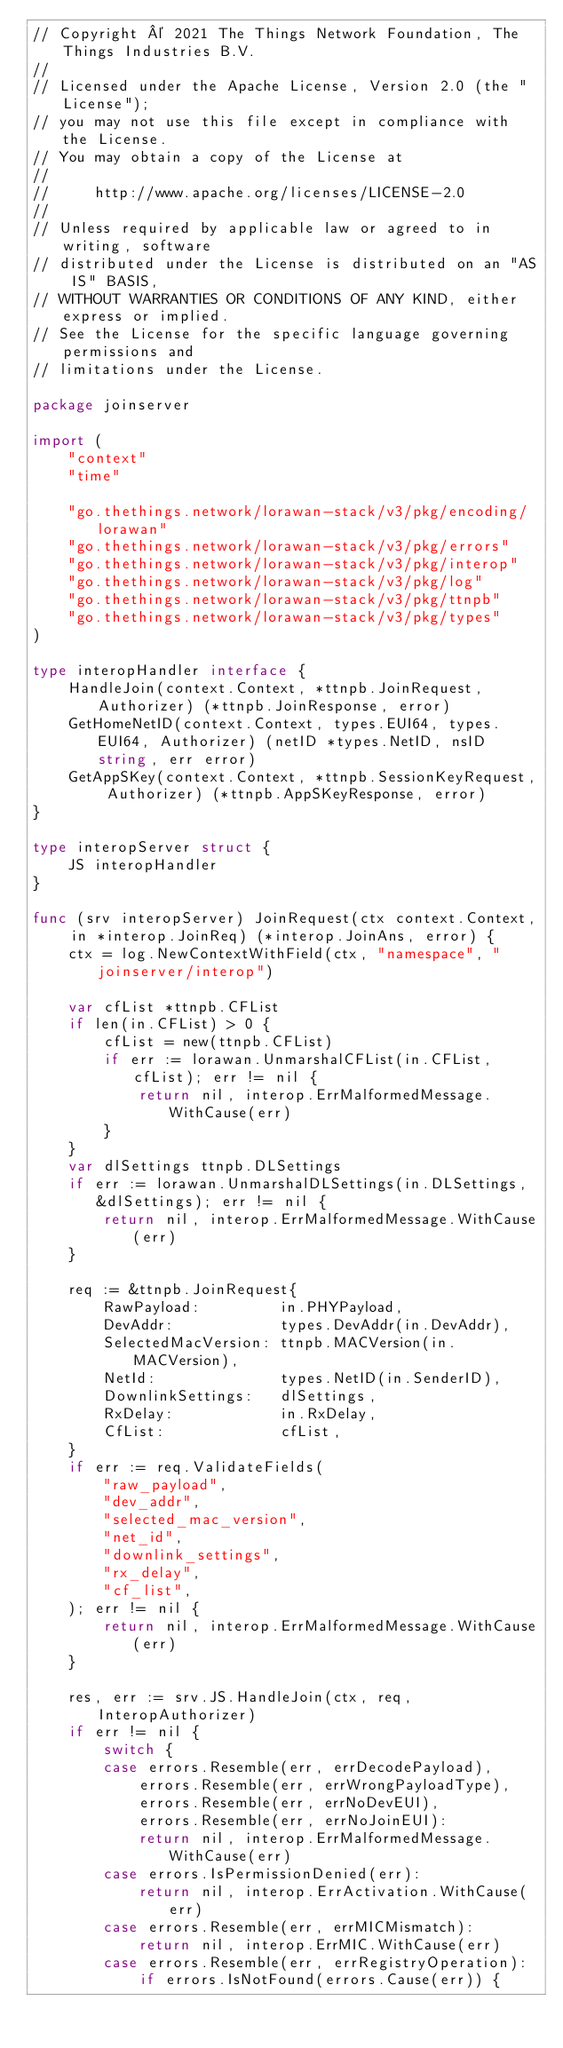<code> <loc_0><loc_0><loc_500><loc_500><_Go_>// Copyright © 2021 The Things Network Foundation, The Things Industries B.V.
//
// Licensed under the Apache License, Version 2.0 (the "License");
// you may not use this file except in compliance with the License.
// You may obtain a copy of the License at
//
//     http://www.apache.org/licenses/LICENSE-2.0
//
// Unless required by applicable law or agreed to in writing, software
// distributed under the License is distributed on an "AS IS" BASIS,
// WITHOUT WARRANTIES OR CONDITIONS OF ANY KIND, either express or implied.
// See the License for the specific language governing permissions and
// limitations under the License.

package joinserver

import (
	"context"
	"time"

	"go.thethings.network/lorawan-stack/v3/pkg/encoding/lorawan"
	"go.thethings.network/lorawan-stack/v3/pkg/errors"
	"go.thethings.network/lorawan-stack/v3/pkg/interop"
	"go.thethings.network/lorawan-stack/v3/pkg/log"
	"go.thethings.network/lorawan-stack/v3/pkg/ttnpb"
	"go.thethings.network/lorawan-stack/v3/pkg/types"
)

type interopHandler interface {
	HandleJoin(context.Context, *ttnpb.JoinRequest, Authorizer) (*ttnpb.JoinResponse, error)
	GetHomeNetID(context.Context, types.EUI64, types.EUI64, Authorizer) (netID *types.NetID, nsID string, err error)
	GetAppSKey(context.Context, *ttnpb.SessionKeyRequest, Authorizer) (*ttnpb.AppSKeyResponse, error)
}

type interopServer struct {
	JS interopHandler
}

func (srv interopServer) JoinRequest(ctx context.Context, in *interop.JoinReq) (*interop.JoinAns, error) {
	ctx = log.NewContextWithField(ctx, "namespace", "joinserver/interop")

	var cfList *ttnpb.CFList
	if len(in.CFList) > 0 {
		cfList = new(ttnpb.CFList)
		if err := lorawan.UnmarshalCFList(in.CFList, cfList); err != nil {
			return nil, interop.ErrMalformedMessage.WithCause(err)
		}
	}
	var dlSettings ttnpb.DLSettings
	if err := lorawan.UnmarshalDLSettings(in.DLSettings, &dlSettings); err != nil {
		return nil, interop.ErrMalformedMessage.WithCause(err)
	}

	req := &ttnpb.JoinRequest{
		RawPayload:         in.PHYPayload,
		DevAddr:            types.DevAddr(in.DevAddr),
		SelectedMacVersion: ttnpb.MACVersion(in.MACVersion),
		NetId:              types.NetID(in.SenderID),
		DownlinkSettings:   dlSettings,
		RxDelay:            in.RxDelay,
		CfList:             cfList,
	}
	if err := req.ValidateFields(
		"raw_payload",
		"dev_addr",
		"selected_mac_version",
		"net_id",
		"downlink_settings",
		"rx_delay",
		"cf_list",
	); err != nil {
		return nil, interop.ErrMalformedMessage.WithCause(err)
	}

	res, err := srv.JS.HandleJoin(ctx, req, InteropAuthorizer)
	if err != nil {
		switch {
		case errors.Resemble(err, errDecodePayload),
			errors.Resemble(err, errWrongPayloadType),
			errors.Resemble(err, errNoDevEUI),
			errors.Resemble(err, errNoJoinEUI):
			return nil, interop.ErrMalformedMessage.WithCause(err)
		case errors.IsPermissionDenied(err):
			return nil, interop.ErrActivation.WithCause(err)
		case errors.Resemble(err, errMICMismatch):
			return nil, interop.ErrMIC.WithCause(err)
		case errors.Resemble(err, errRegistryOperation):
			if errors.IsNotFound(errors.Cause(err)) {</code> 